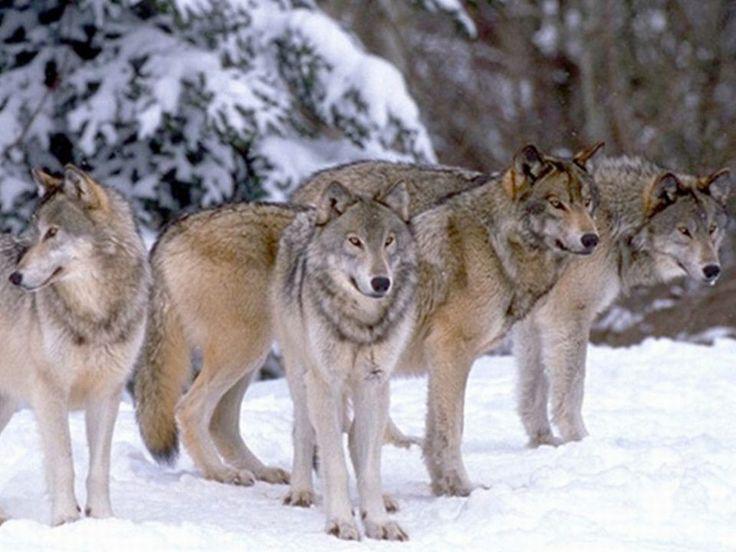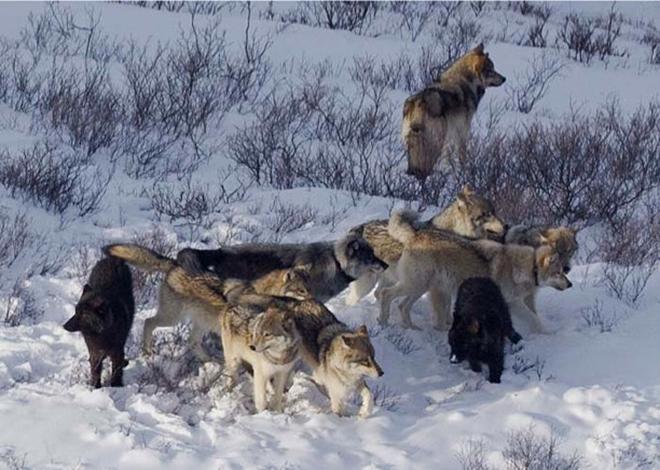The first image is the image on the left, the second image is the image on the right. Considering the images on both sides, is "Each image shows at least three wolves in a snowy scene, and no carcass is visible in either scene." valid? Answer yes or no. Yes. The first image is the image on the left, the second image is the image on the right. Considering the images on both sides, is "There are more than six wolves." valid? Answer yes or no. Yes. 